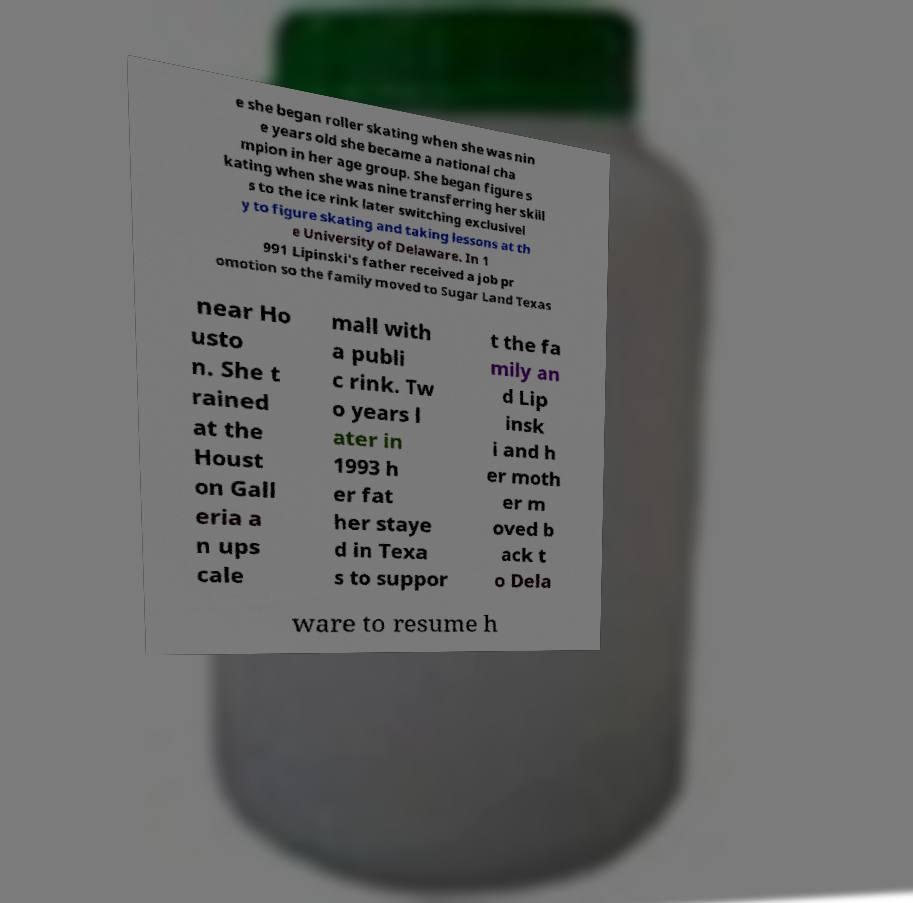Please read and relay the text visible in this image. What does it say? e she began roller skating when she was nin e years old she became a national cha mpion in her age group. She began figure s kating when she was nine transferring her skill s to the ice rink later switching exclusivel y to figure skating and taking lessons at th e University of Delaware. In 1 991 Lipinski's father received a job pr omotion so the family moved to Sugar Land Texas near Ho usto n. She t rained at the Houst on Gall eria a n ups cale mall with a publi c rink. Tw o years l ater in 1993 h er fat her staye d in Texa s to suppor t the fa mily an d Lip insk i and h er moth er m oved b ack t o Dela ware to resume h 